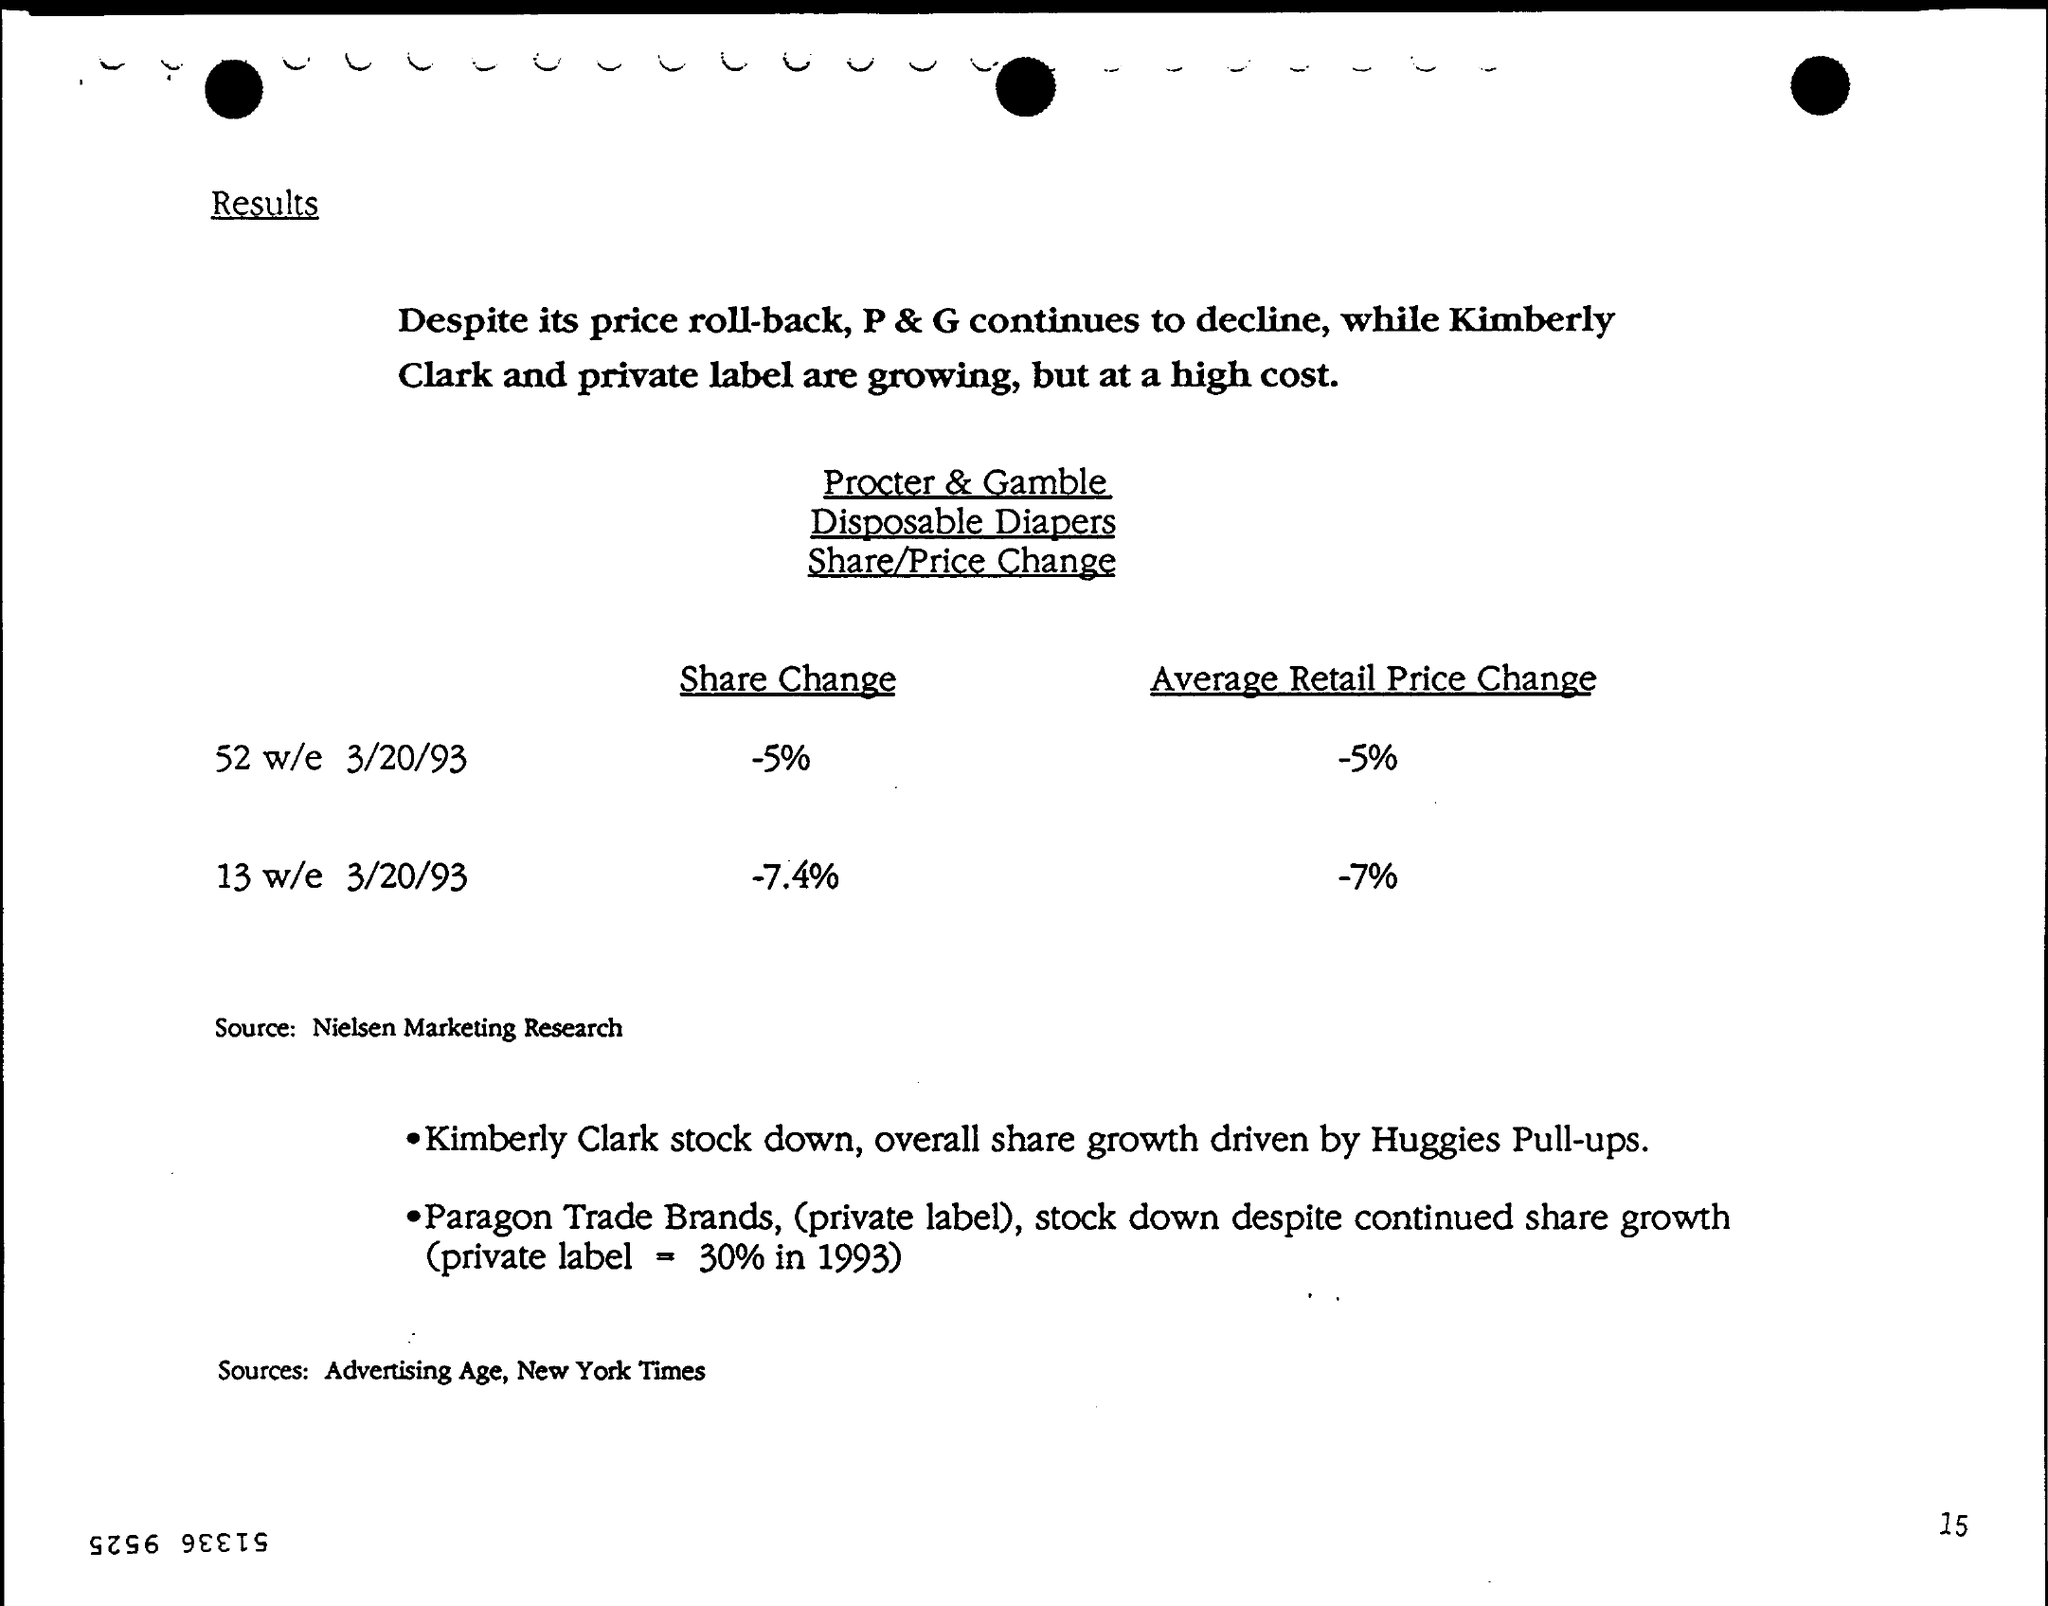How much Average Retail price change for 52 w/e 3/20/93 ?
Provide a short and direct response. -5%. How much Share Change for 13 w/e 3/20/93 ?
Provide a succinct answer. -7.4%. 